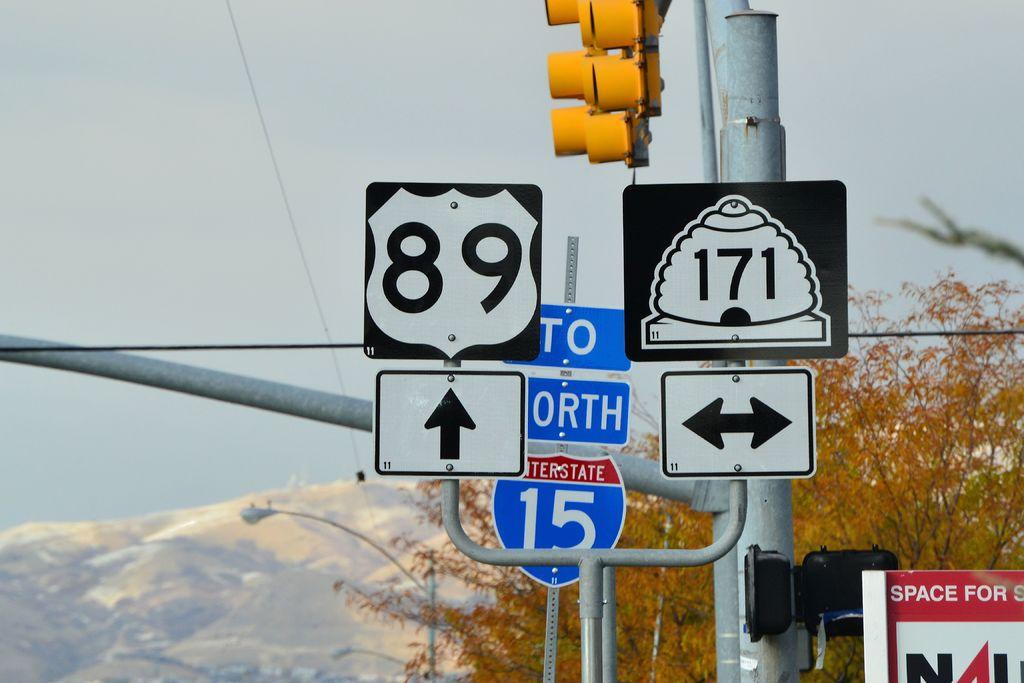Which road runs east and west?
Keep it short and to the point. 171. 